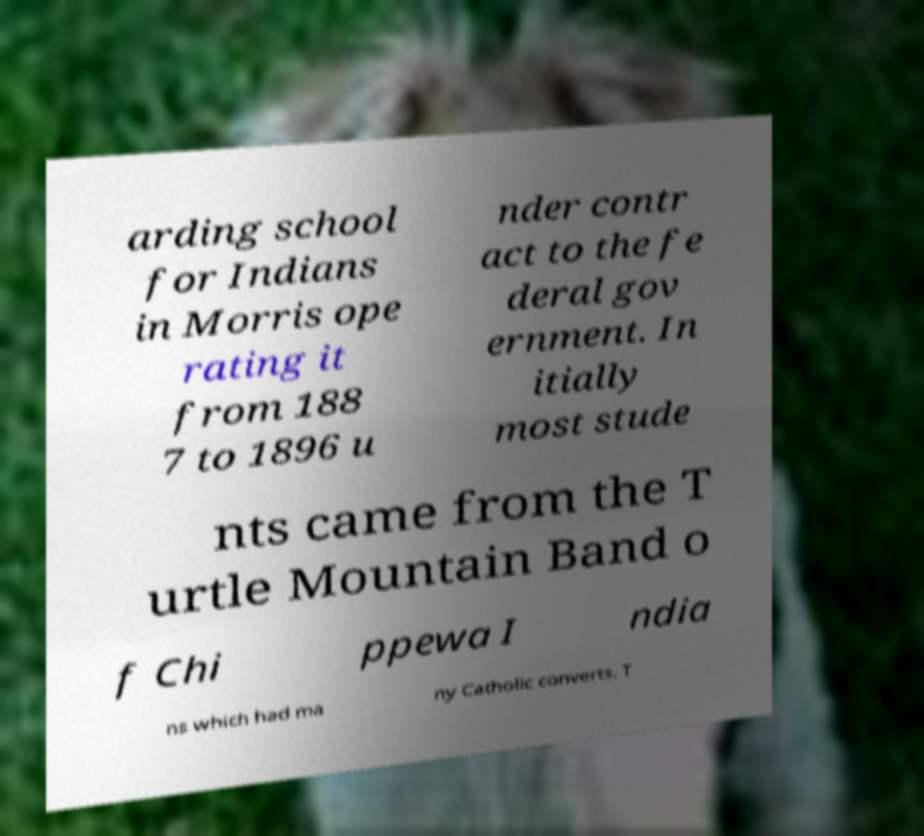For documentation purposes, I need the text within this image transcribed. Could you provide that? arding school for Indians in Morris ope rating it from 188 7 to 1896 u nder contr act to the fe deral gov ernment. In itially most stude nts came from the T urtle Mountain Band o f Chi ppewa I ndia ns which had ma ny Catholic converts. T 